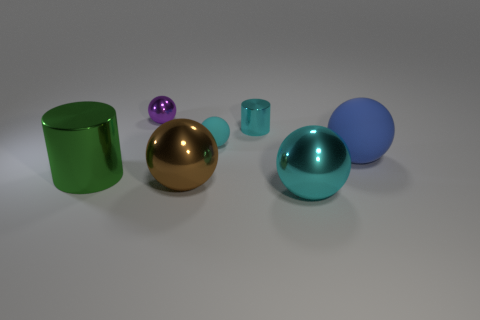How do the objects in the image differ in texture and what might that imply about their material composition? The objects vary from smooth and highly reflective surfaces to matte and less reflective ones. This suggests differences in material, with the glossy objects likely being metallic or plastic, and the matte objects possibly made of ceramics or painted surfaces. 